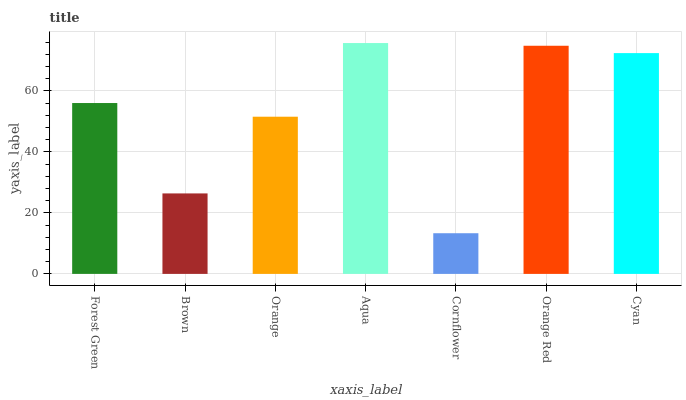Is Cornflower the minimum?
Answer yes or no. Yes. Is Aqua the maximum?
Answer yes or no. Yes. Is Brown the minimum?
Answer yes or no. No. Is Brown the maximum?
Answer yes or no. No. Is Forest Green greater than Brown?
Answer yes or no. Yes. Is Brown less than Forest Green?
Answer yes or no. Yes. Is Brown greater than Forest Green?
Answer yes or no. No. Is Forest Green less than Brown?
Answer yes or no. No. Is Forest Green the high median?
Answer yes or no. Yes. Is Forest Green the low median?
Answer yes or no. Yes. Is Orange the high median?
Answer yes or no. No. Is Cyan the low median?
Answer yes or no. No. 